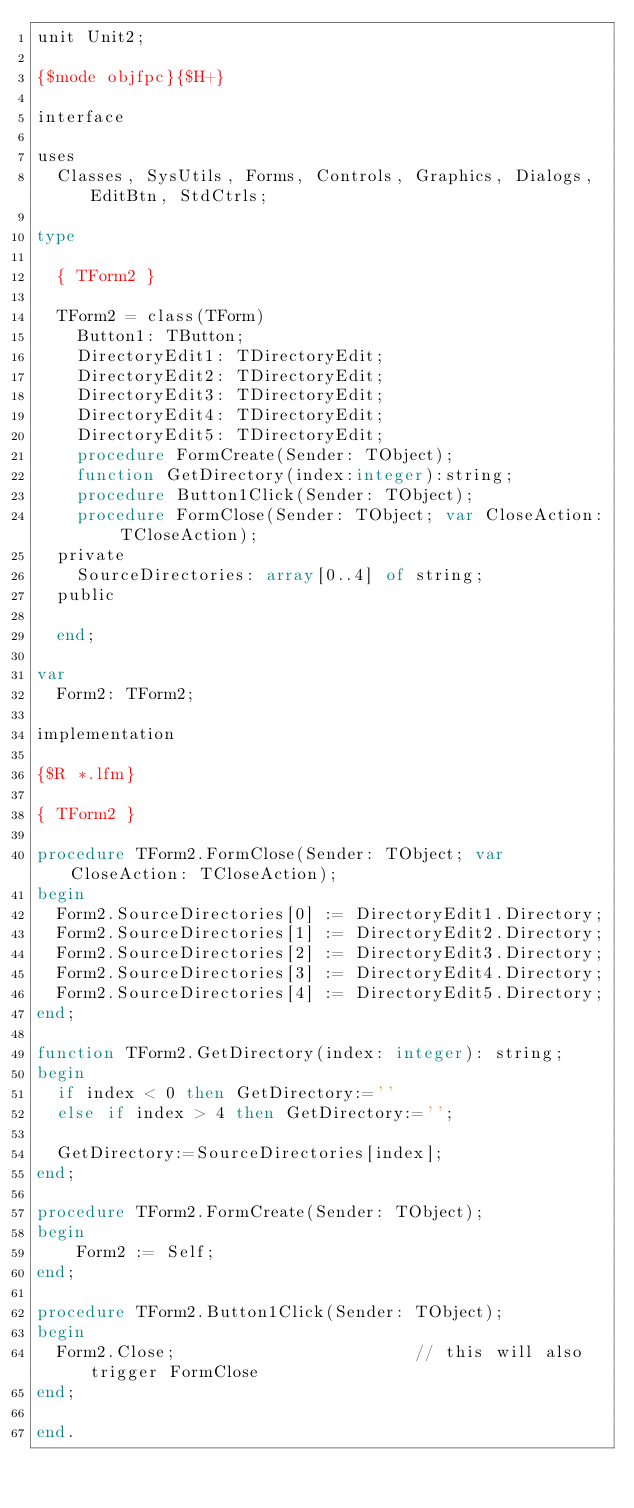<code> <loc_0><loc_0><loc_500><loc_500><_Pascal_>unit Unit2;

{$mode objfpc}{$H+}

interface

uses
  Classes, SysUtils, Forms, Controls, Graphics, Dialogs, EditBtn, StdCtrls;

type

  { TForm2 }

  TForm2 = class(TForm)
    Button1: TButton;
    DirectoryEdit1: TDirectoryEdit;
    DirectoryEdit2: TDirectoryEdit;
    DirectoryEdit3: TDirectoryEdit;
    DirectoryEdit4: TDirectoryEdit;
    DirectoryEdit5: TDirectoryEdit;
    procedure FormCreate(Sender: TObject);
    function GetDirectory(index:integer):string;
    procedure Button1Click(Sender: TObject);
    procedure FormClose(Sender: TObject; var CloseAction: TCloseAction);
  private
    SourceDirectories: array[0..4] of string;
  public

  end;

var
  Form2: TForm2;

implementation

{$R *.lfm}

{ TForm2 }

procedure TForm2.FormClose(Sender: TObject; var CloseAction: TCloseAction);
begin
  Form2.SourceDirectories[0] := DirectoryEdit1.Directory;
  Form2.SourceDirectories[1] := DirectoryEdit2.Directory;
  Form2.SourceDirectories[2] := DirectoryEdit3.Directory;
  Form2.SourceDirectories[3] := DirectoryEdit4.Directory;
  Form2.SourceDirectories[4] := DirectoryEdit5.Directory;
end;

function TForm2.GetDirectory(index: integer): string;
begin
  if index < 0 then GetDirectory:=''
  else if index > 4 then GetDirectory:='';

  GetDirectory:=SourceDirectories[index];
end;

procedure TForm2.FormCreate(Sender: TObject);
begin
    Form2 := Self;
end;

procedure TForm2.Button1Click(Sender: TObject);
begin
  Form2.Close;                        // this will also trigger FormClose
end;

end.

</code> 